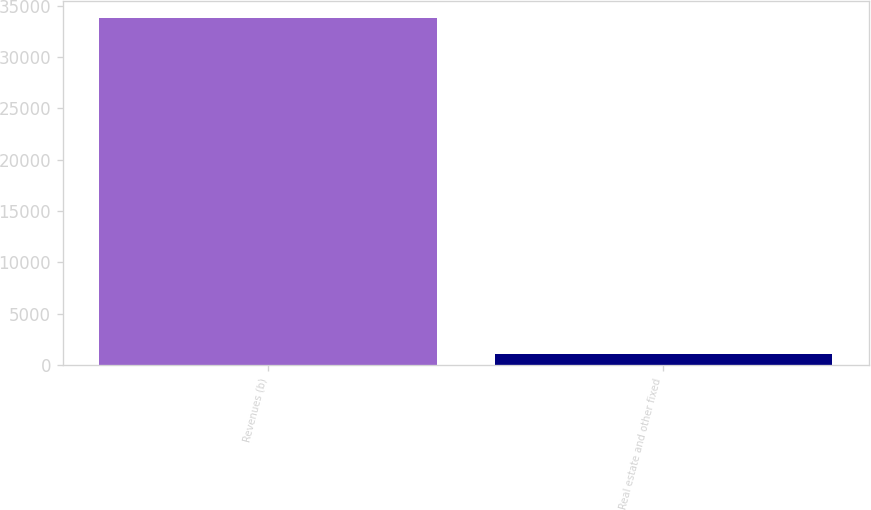Convert chart. <chart><loc_0><loc_0><loc_500><loc_500><bar_chart><fcel>Revenues (b)<fcel>Real estate and other fixed<nl><fcel>33795<fcel>1082<nl></chart> 